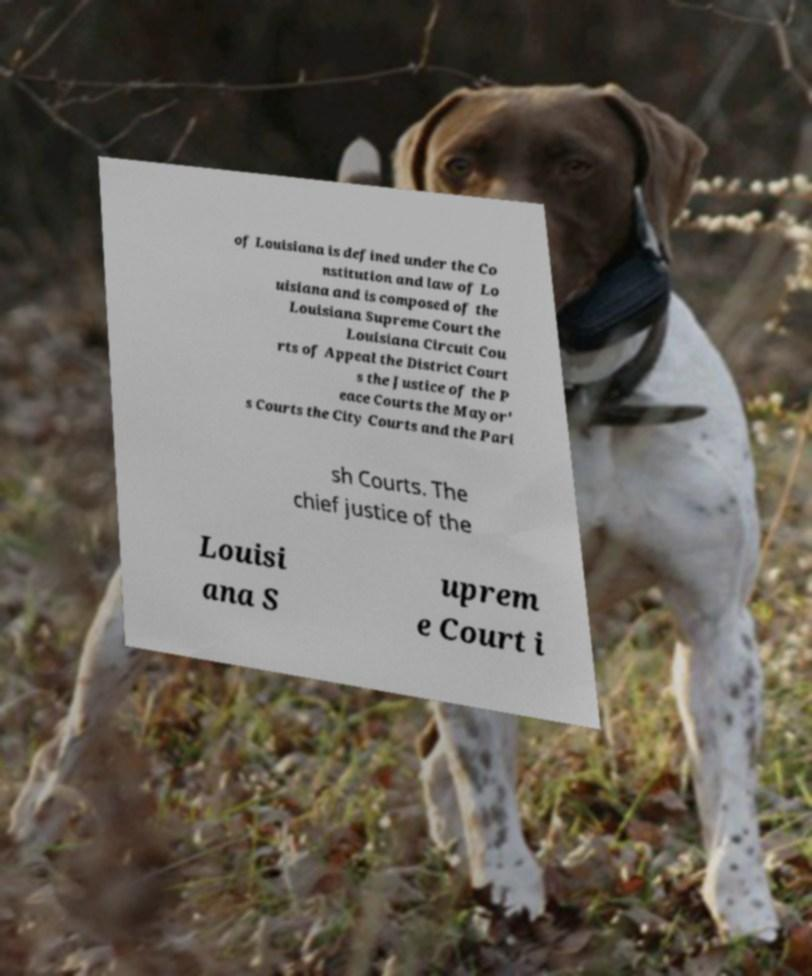Please read and relay the text visible in this image. What does it say? of Louisiana is defined under the Co nstitution and law of Lo uisiana and is composed of the Louisiana Supreme Court the Louisiana Circuit Cou rts of Appeal the District Court s the Justice of the P eace Courts the Mayor' s Courts the City Courts and the Pari sh Courts. The chief justice of the Louisi ana S uprem e Court i 